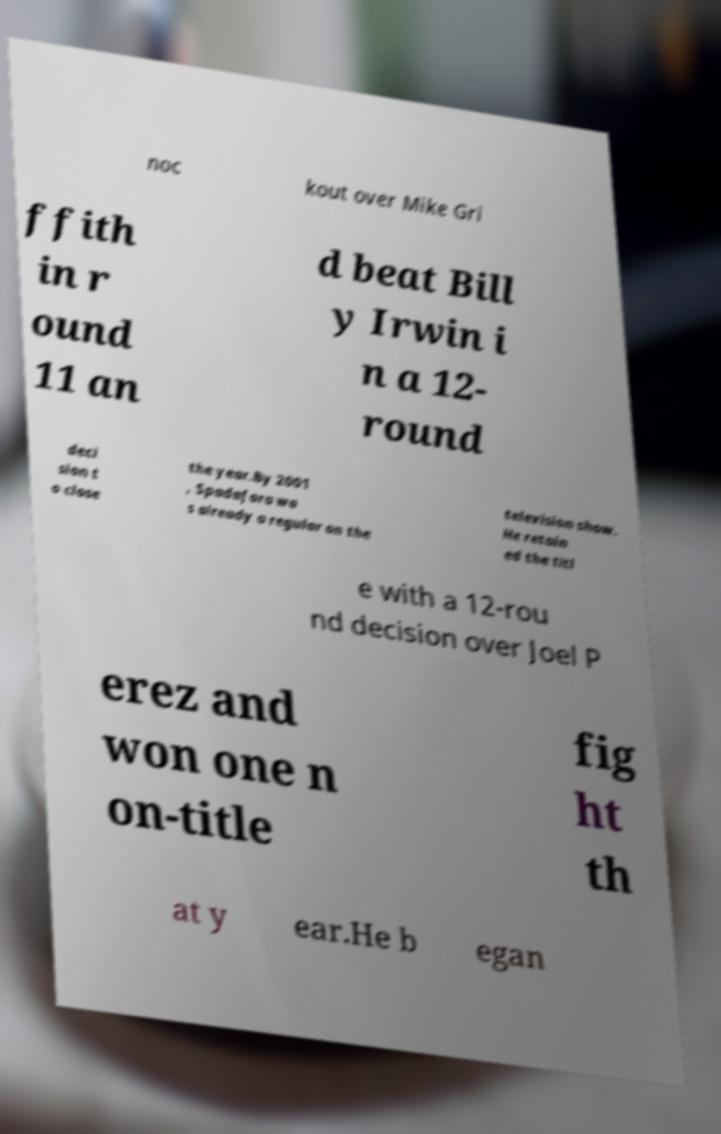Could you extract and type out the text from this image? noc kout over Mike Gri ffith in r ound 11 an d beat Bill y Irwin i n a 12- round deci sion t o close the year.By 2001 , Spadafora wa s already a regular on the television show. He retain ed the titl e with a 12-rou nd decision over Joel P erez and won one n on-title fig ht th at y ear.He b egan 